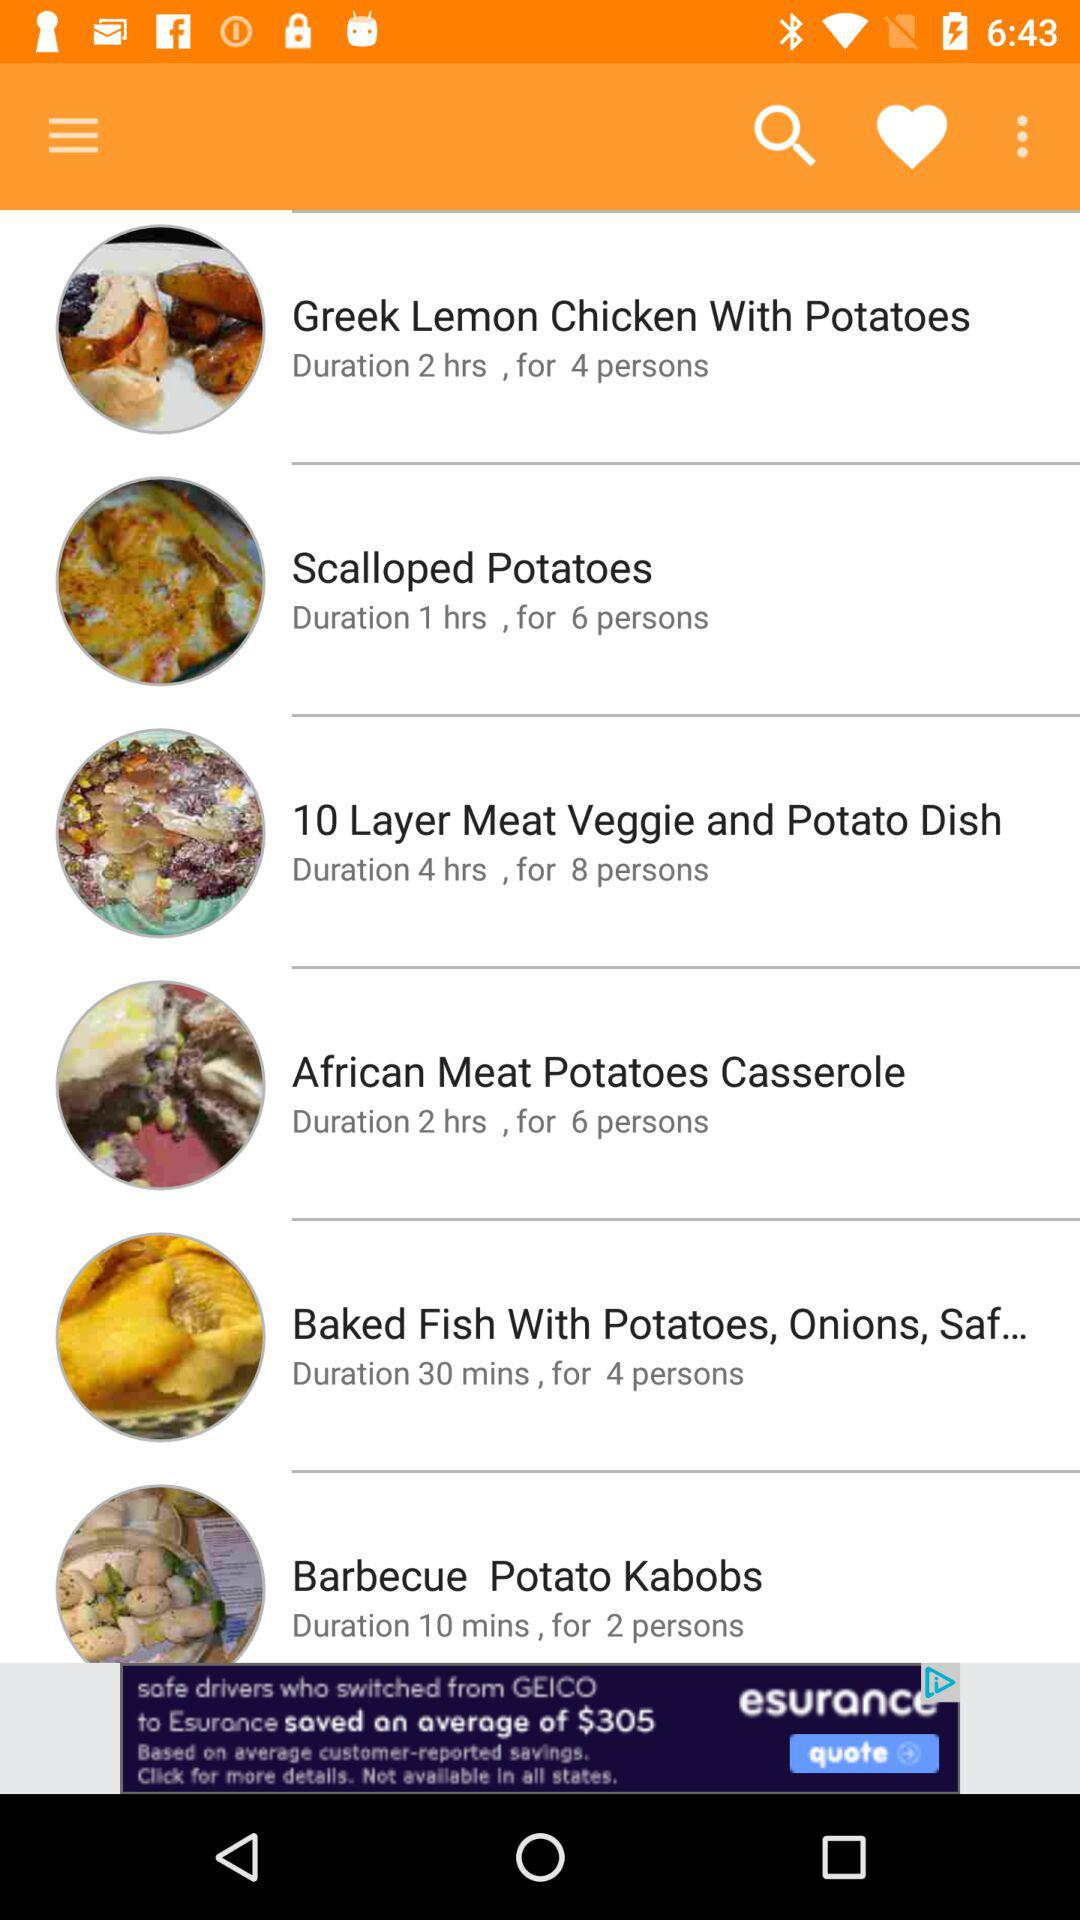How many people is "Greek Lemon Chicken With Potatoes" for? The "Greek Lemon Chicken With Potatoes" is for 4 people. 